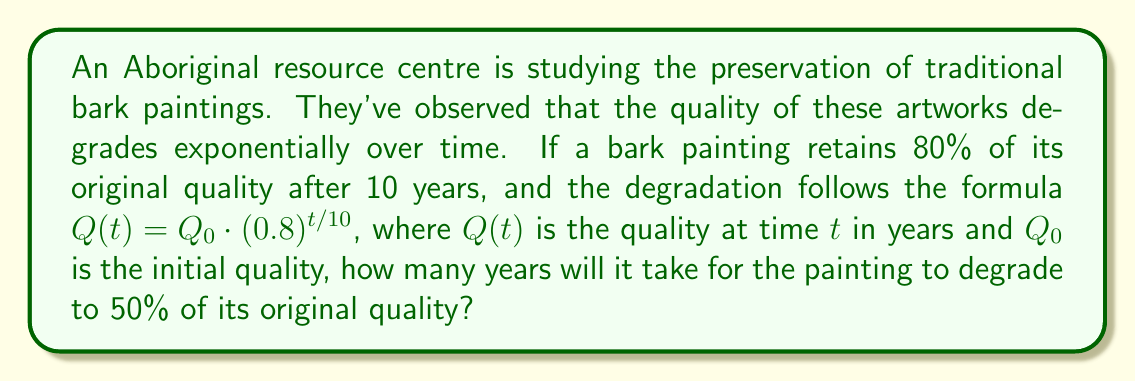Can you solve this math problem? Let's approach this step-by-step:

1) We're given the formula $Q(t) = Q_0 \cdot (0.8)^{t/10}$

2) We want to find $t$ when $Q(t) = 0.5Q_0$

3) Let's substitute these into the equation:
   
   $0.5Q_0 = Q_0 \cdot (0.8)^{t/10}$

4) We can simplify by dividing both sides by $Q_0$:
   
   $0.5 = (0.8)^{t/10}$

5) Now, let's take the logarithm of both sides. We'll use log base 0.8 for simplicity:
   
   $\log_{0.8}(0.5) = \log_{0.8}((0.8)^{t/10})$

6) The right side simplifies due to the logarithm rule $\log_a(a^x) = x$:
   
   $\log_{0.8}(0.5) = t/10$

7) Multiply both sides by 10:
   
   $10 \log_{0.8}(0.5) = t$

8) We can calculate this using the change of base formula:
   
   $t = 10 \cdot \frac{\log(0.5)}{\log(0.8)} \approx 28.85$ years
Answer: $\approx 28.85$ years 